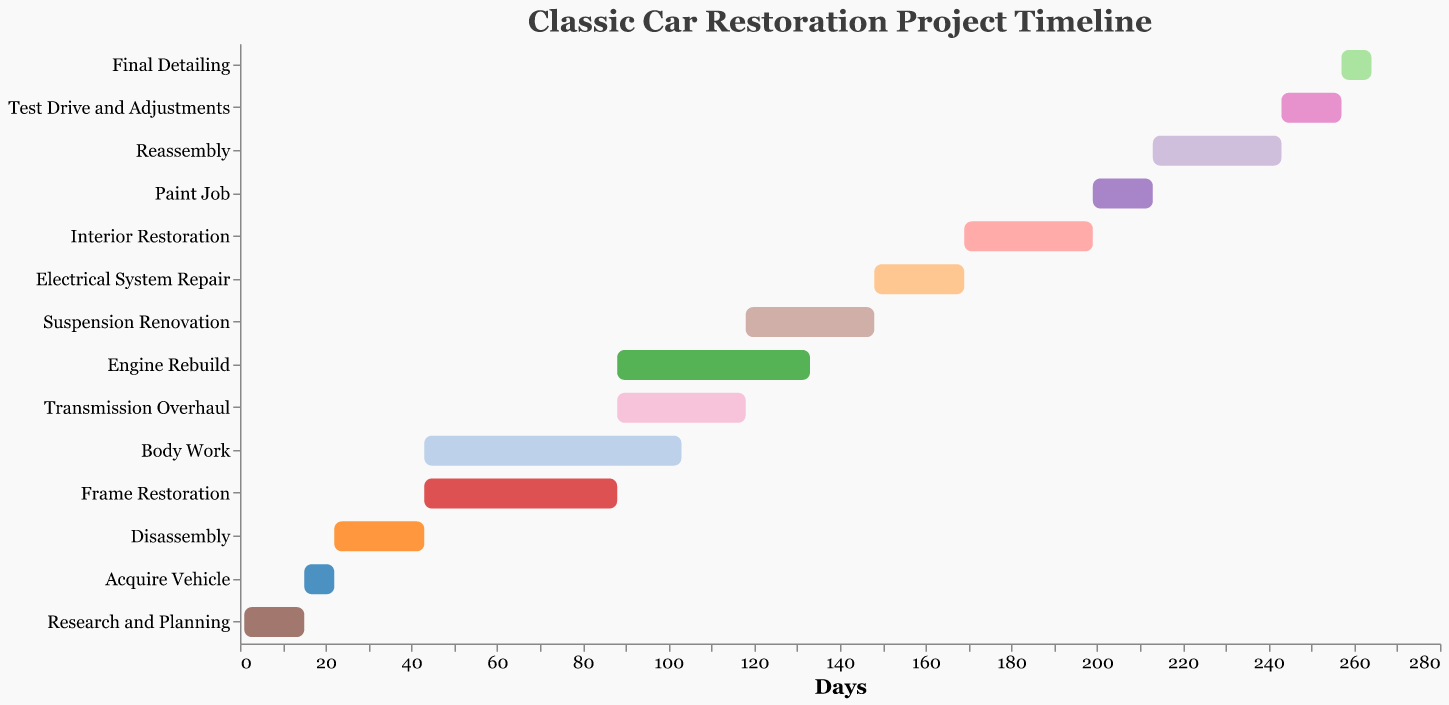What is the duration of the "Paint Job" stage? According to the Gantt chart, the "Paint Job" stage starts on day 199 and lasts for 14 days, as specified in the data.
Answer: 14 days When does the "Engine Rebuild" stage begin and end? The "Engine Rebuild" stage starts on day 88 and lasts for 45 days, according to the chart. This means it ends on day 133 (88 + 45).
Answer: Starts on day 88, ends on day 133 Which stage takes the longest to complete? By looking at the durations of all stages in the Gantt chart, the "Body Work" stage has the longest duration of 60 days.
Answer: Body Work How many stages are running concurrently on day 100? On day 100, three stages are concurrently running: "Body Work," "Frame Restoration," and "Engine Rebuild."
Answer: 3 stages Which stage starts immediately after "Disassembly"? According to the Gantt chart, "Body Work" and "Frame Restoration" both start immediately after "Disassembly," which ends on day 43.
Answer: Body Work and Frame Restoration How long does it take to complete both "Suspension Renovation" and "Electrical System Repair"? "Suspension Renovation" lasts for 30 days, and "Electrical System Repair" lasts for 21 days, so combined, they take 30 + 21 = 51 days to complete.
Answer: 51 days Which stage has the shortest duration? The "Final Detailing" stage has the shortest duration of 7 days, according to the Gantt chart.
Answer: Final Detailing What is the total duration for "Reassembly" and "Test Drive and Adjustments"? "Reassembly" lasts for 30 days, and "Test Drive and Adjustments" lasts for 14 days. Therefore, the total duration is 30 + 14 = 44 days.
Answer: 44 days Are there any stages starting simultaneously, and if so, which ones? Yes, "Body Work" and "Frame Restoration" both start on day 43, and "Engine Rebuild" and "Transmission Overhaul" both start on day 88.
Answer: Body Work and Frame Restoration; Engine Rebuild and Transmission Overhaul 